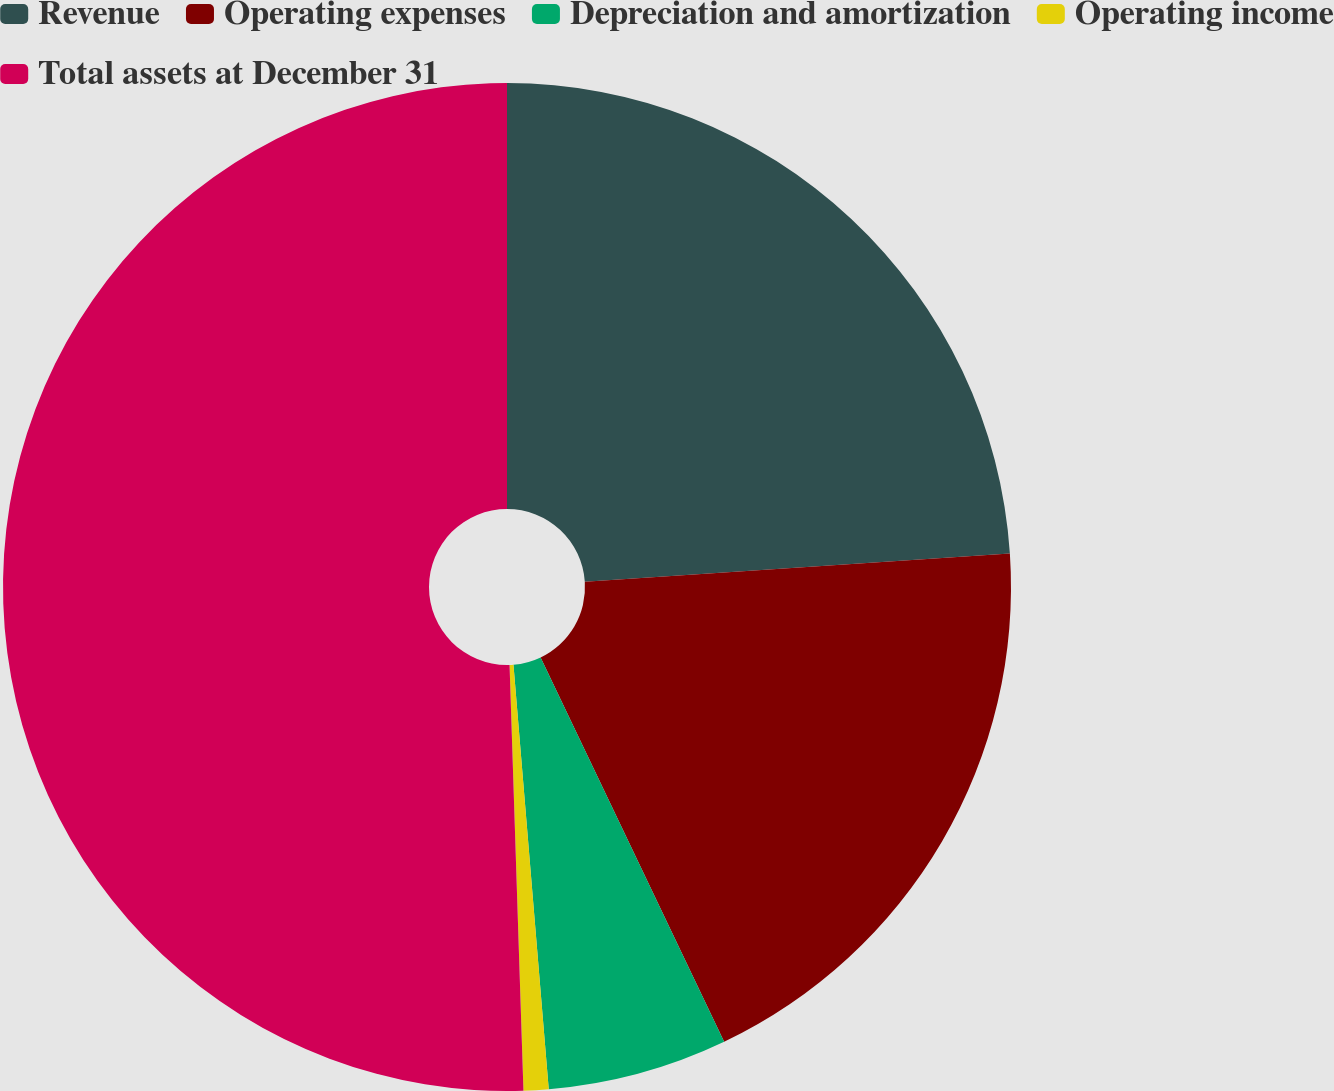<chart> <loc_0><loc_0><loc_500><loc_500><pie_chart><fcel>Revenue<fcel>Operating expenses<fcel>Depreciation and amortization<fcel>Operating income<fcel>Total assets at December 31<nl><fcel>23.94%<fcel>18.97%<fcel>5.77%<fcel>0.8%<fcel>50.52%<nl></chart> 